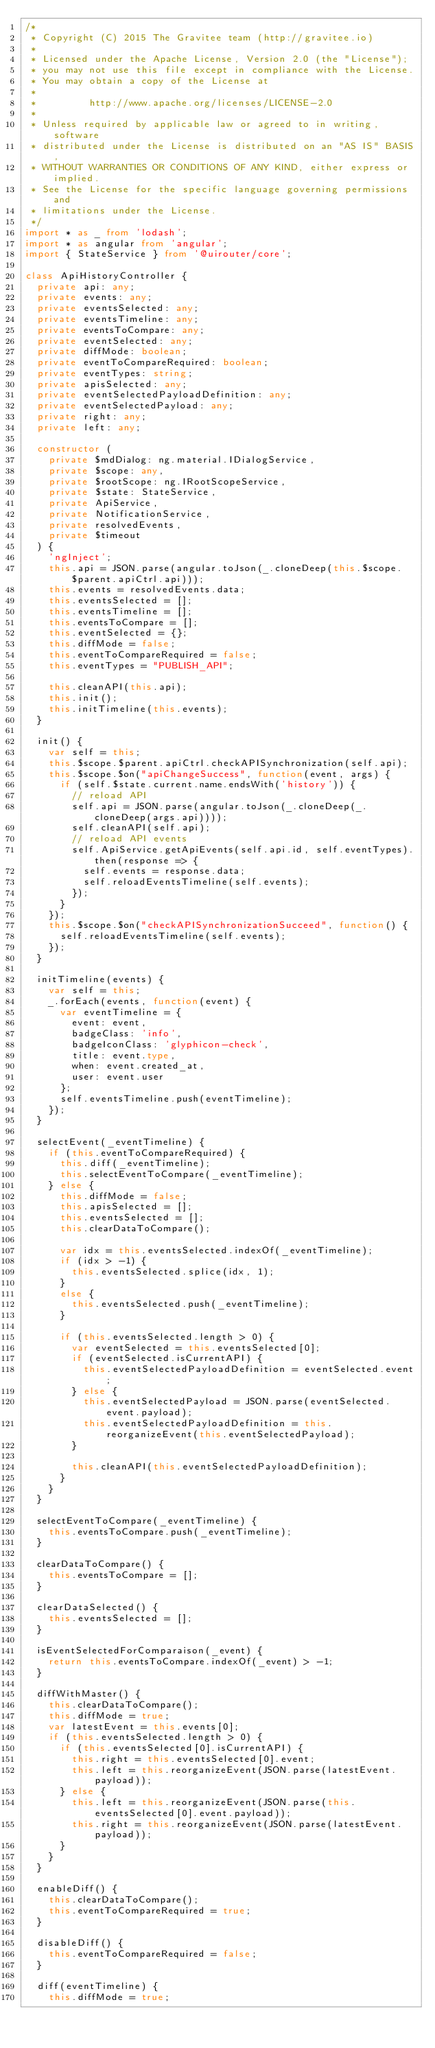<code> <loc_0><loc_0><loc_500><loc_500><_TypeScript_>/*
 * Copyright (C) 2015 The Gravitee team (http://gravitee.io)
 *
 * Licensed under the Apache License, Version 2.0 (the "License");
 * you may not use this file except in compliance with the License.
 * You may obtain a copy of the License at
 *
 *         http://www.apache.org/licenses/LICENSE-2.0
 *
 * Unless required by applicable law or agreed to in writing, software
 * distributed under the License is distributed on an "AS IS" BASIS,
 * WITHOUT WARRANTIES OR CONDITIONS OF ANY KIND, either express or implied.
 * See the License for the specific language governing permissions and
 * limitations under the License.
 */
import * as _ from 'lodash';
import * as angular from 'angular';
import { StateService } from '@uirouter/core';

class ApiHistoryController {
  private api: any;
  private events: any;
  private eventsSelected: any;
  private eventsTimeline: any;
  private eventsToCompare: any;
  private eventSelected: any;
  private diffMode: boolean;
  private eventToCompareRequired: boolean;
  private eventTypes: string;
  private apisSelected: any;
  private eventSelectedPayloadDefinition: any;
  private eventSelectedPayload: any;
  private right: any;
  private left: any;

  constructor (
    private $mdDialog: ng.material.IDialogService,
    private $scope: any,
    private $rootScope: ng.IRootScopeService,
    private $state: StateService,
    private ApiService,
    private NotificationService,
    private resolvedEvents,
    private $timeout
  ) {
    'ngInject';
    this.api = JSON.parse(angular.toJson(_.cloneDeep(this.$scope.$parent.apiCtrl.api)));
    this.events = resolvedEvents.data;
    this.eventsSelected = [];
    this.eventsTimeline = [];
    this.eventsToCompare = [];
    this.eventSelected = {};
    this.diffMode = false;
    this.eventToCompareRequired = false;
    this.eventTypes = "PUBLISH_API";

    this.cleanAPI(this.api);
    this.init();
    this.initTimeline(this.events);
  }

  init() {
    var self = this;
    this.$scope.$parent.apiCtrl.checkAPISynchronization(self.api);
    this.$scope.$on("apiChangeSuccess", function(event, args) {
      if (self.$state.current.name.endsWith('history')) {
        // reload API
        self.api = JSON.parse(angular.toJson(_.cloneDeep(_.cloneDeep(args.api))));
        self.cleanAPI(self.api);
        // reload API events
        self.ApiService.getApiEvents(self.api.id, self.eventTypes).then(response => {
          self.events = response.data;
          self.reloadEventsTimeline(self.events);
        });
      }
    });
    this.$scope.$on("checkAPISynchronizationSucceed", function() {
      self.reloadEventsTimeline(self.events);
    });
  }

  initTimeline(events) {
    var self = this;
    _.forEach(events, function(event) {
      var eventTimeline = {
        event: event,
        badgeClass: 'info',
        badgeIconClass: 'glyphicon-check',
        title: event.type,
        when: event.created_at,
        user: event.user
      };
      self.eventsTimeline.push(eventTimeline);
    });
  }

  selectEvent(_eventTimeline) {
    if (this.eventToCompareRequired) {
      this.diff(_eventTimeline);
      this.selectEventToCompare(_eventTimeline);
    } else {
      this.diffMode = false;
      this.apisSelected = [];
      this.eventsSelected = [];
      this.clearDataToCompare();

      var idx = this.eventsSelected.indexOf(_eventTimeline);
      if (idx > -1) {
        this.eventsSelected.splice(idx, 1);
      }
      else {
        this.eventsSelected.push(_eventTimeline);
      }

      if (this.eventsSelected.length > 0) {
        var eventSelected = this.eventsSelected[0];
        if (eventSelected.isCurrentAPI) {
          this.eventSelectedPayloadDefinition = eventSelected.event;
        } else {
          this.eventSelectedPayload = JSON.parse(eventSelected.event.payload);
          this.eventSelectedPayloadDefinition = this.reorganizeEvent(this.eventSelectedPayload);
        }

        this.cleanAPI(this.eventSelectedPayloadDefinition);
      }
    }
  }

  selectEventToCompare(_eventTimeline) {
    this.eventsToCompare.push(_eventTimeline);
  }

  clearDataToCompare() {
    this.eventsToCompare = [];
  }

  clearDataSelected() {
    this.eventsSelected = [];
  }

  isEventSelectedForComparaison(_event) {
    return this.eventsToCompare.indexOf(_event) > -1;
  }

  diffWithMaster() {
    this.clearDataToCompare();
    this.diffMode = true;
    var latestEvent = this.events[0];
    if (this.eventsSelected.length > 0) {
      if (this.eventsSelected[0].isCurrentAPI) {
        this.right = this.eventsSelected[0].event;
        this.left = this.reorganizeEvent(JSON.parse(latestEvent.payload));
      } else {
        this.left = this.reorganizeEvent(JSON.parse(this.eventsSelected[0].event.payload));
        this.right = this.reorganizeEvent(JSON.parse(latestEvent.payload));
      }
    }
  }

  enableDiff() {
    this.clearDataToCompare();
    this.eventToCompareRequired = true;
  }

  disableDiff() {
    this.eventToCompareRequired = false;
  }

  diff(eventTimeline) {
    this.diffMode = true;</code> 